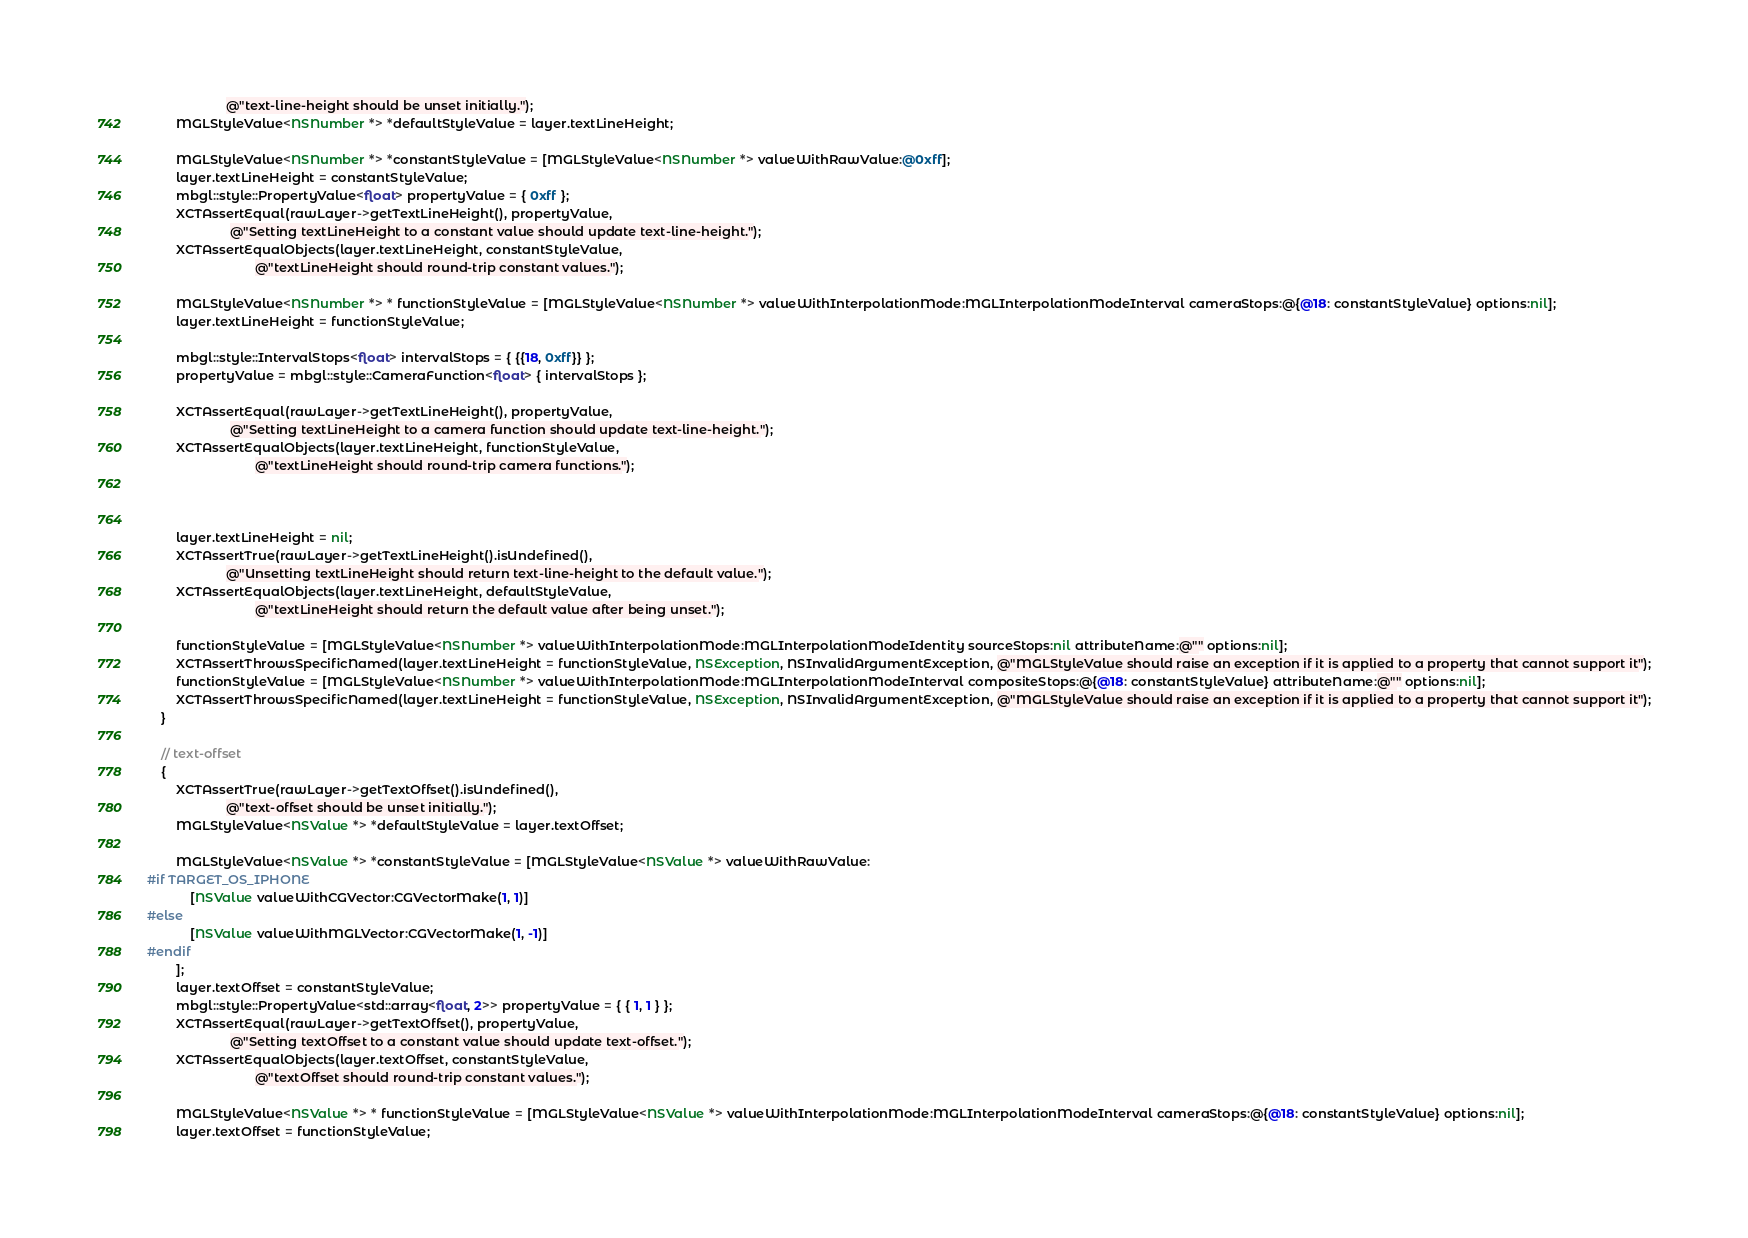Convert code to text. <code><loc_0><loc_0><loc_500><loc_500><_ObjectiveC_>                      @"text-line-height should be unset initially.");
        MGLStyleValue<NSNumber *> *defaultStyleValue = layer.textLineHeight;

        MGLStyleValue<NSNumber *> *constantStyleValue = [MGLStyleValue<NSNumber *> valueWithRawValue:@0xff];
        layer.textLineHeight = constantStyleValue;
        mbgl::style::PropertyValue<float> propertyValue = { 0xff };
        XCTAssertEqual(rawLayer->getTextLineHeight(), propertyValue,
                       @"Setting textLineHeight to a constant value should update text-line-height.");
        XCTAssertEqualObjects(layer.textLineHeight, constantStyleValue,
                              @"textLineHeight should round-trip constant values.");

        MGLStyleValue<NSNumber *> * functionStyleValue = [MGLStyleValue<NSNumber *> valueWithInterpolationMode:MGLInterpolationModeInterval cameraStops:@{@18: constantStyleValue} options:nil];
        layer.textLineHeight = functionStyleValue;

        mbgl::style::IntervalStops<float> intervalStops = { {{18, 0xff}} };
        propertyValue = mbgl::style::CameraFunction<float> { intervalStops };
        
        XCTAssertEqual(rawLayer->getTextLineHeight(), propertyValue,
                       @"Setting textLineHeight to a camera function should update text-line-height.");
        XCTAssertEqualObjects(layer.textLineHeight, functionStyleValue,
                              @"textLineHeight should round-trip camera functions.");

                              

        layer.textLineHeight = nil;
        XCTAssertTrue(rawLayer->getTextLineHeight().isUndefined(),
                      @"Unsetting textLineHeight should return text-line-height to the default value.");
        XCTAssertEqualObjects(layer.textLineHeight, defaultStyleValue,
                              @"textLineHeight should return the default value after being unset.");

        functionStyleValue = [MGLStyleValue<NSNumber *> valueWithInterpolationMode:MGLInterpolationModeIdentity sourceStops:nil attributeName:@"" options:nil];
        XCTAssertThrowsSpecificNamed(layer.textLineHeight = functionStyleValue, NSException, NSInvalidArgumentException, @"MGLStyleValue should raise an exception if it is applied to a property that cannot support it");
        functionStyleValue = [MGLStyleValue<NSNumber *> valueWithInterpolationMode:MGLInterpolationModeInterval compositeStops:@{@18: constantStyleValue} attributeName:@"" options:nil];
        XCTAssertThrowsSpecificNamed(layer.textLineHeight = functionStyleValue, NSException, NSInvalidArgumentException, @"MGLStyleValue should raise an exception if it is applied to a property that cannot support it");
    }

    // text-offset
    {
        XCTAssertTrue(rawLayer->getTextOffset().isUndefined(),
                      @"text-offset should be unset initially.");
        MGLStyleValue<NSValue *> *defaultStyleValue = layer.textOffset;

        MGLStyleValue<NSValue *> *constantStyleValue = [MGLStyleValue<NSValue *> valueWithRawValue:
#if TARGET_OS_IPHONE
            [NSValue valueWithCGVector:CGVectorMake(1, 1)]
#else
            [NSValue valueWithMGLVector:CGVectorMake(1, -1)]
#endif
        ];
        layer.textOffset = constantStyleValue;
        mbgl::style::PropertyValue<std::array<float, 2>> propertyValue = { { 1, 1 } };
        XCTAssertEqual(rawLayer->getTextOffset(), propertyValue,
                       @"Setting textOffset to a constant value should update text-offset.");
        XCTAssertEqualObjects(layer.textOffset, constantStyleValue,
                              @"textOffset should round-trip constant values.");

        MGLStyleValue<NSValue *> * functionStyleValue = [MGLStyleValue<NSValue *> valueWithInterpolationMode:MGLInterpolationModeInterval cameraStops:@{@18: constantStyleValue} options:nil];
        layer.textOffset = functionStyleValue;
</code> 